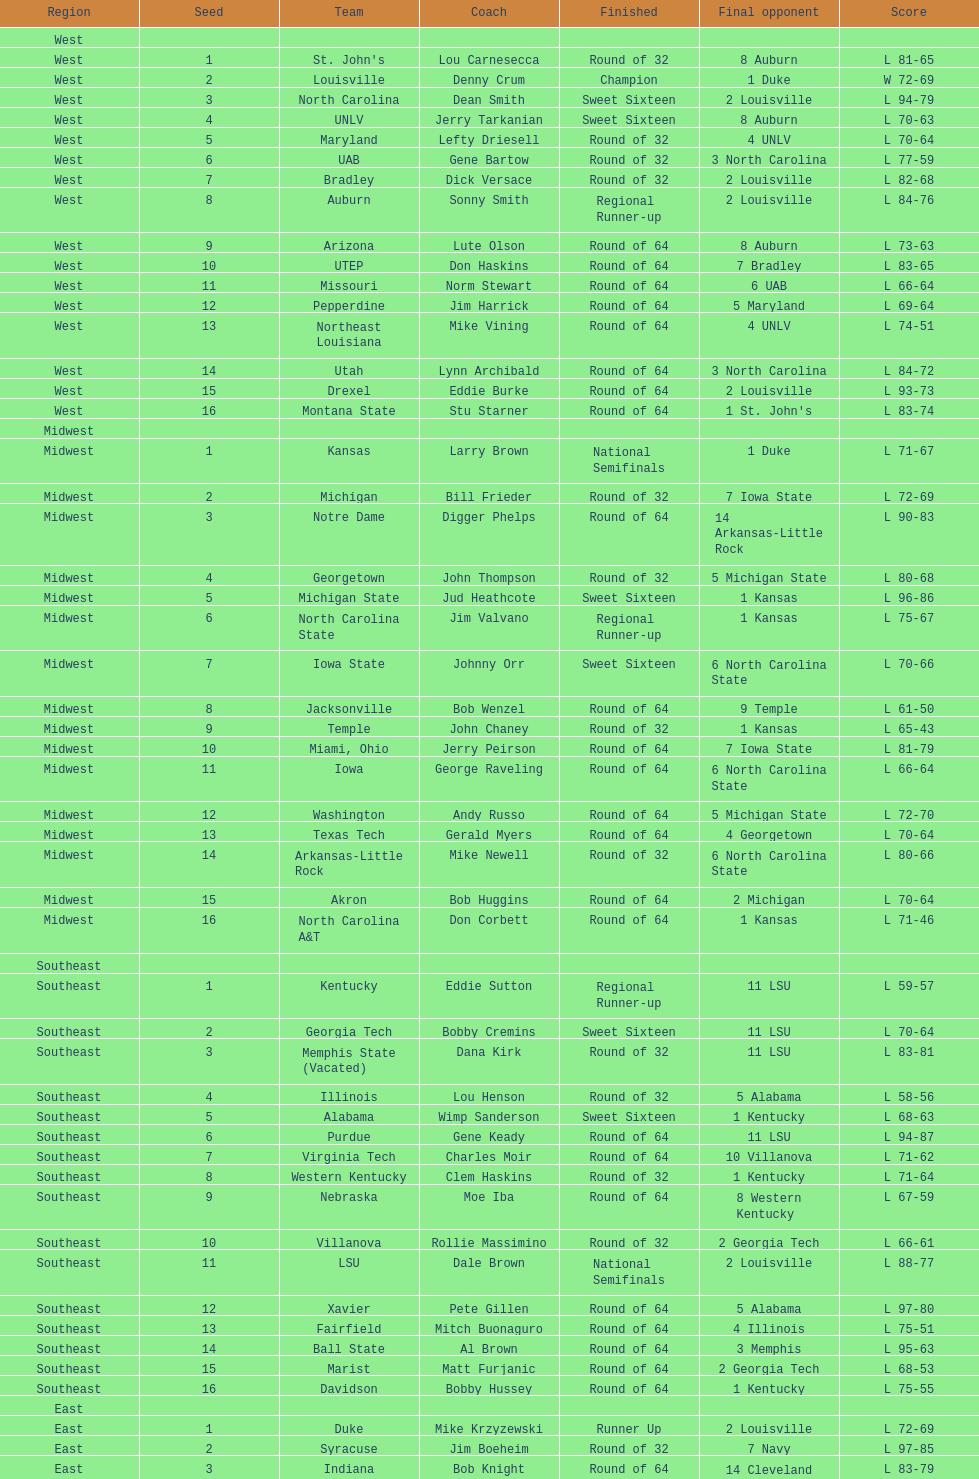How many teams are present in the east region? 16. 